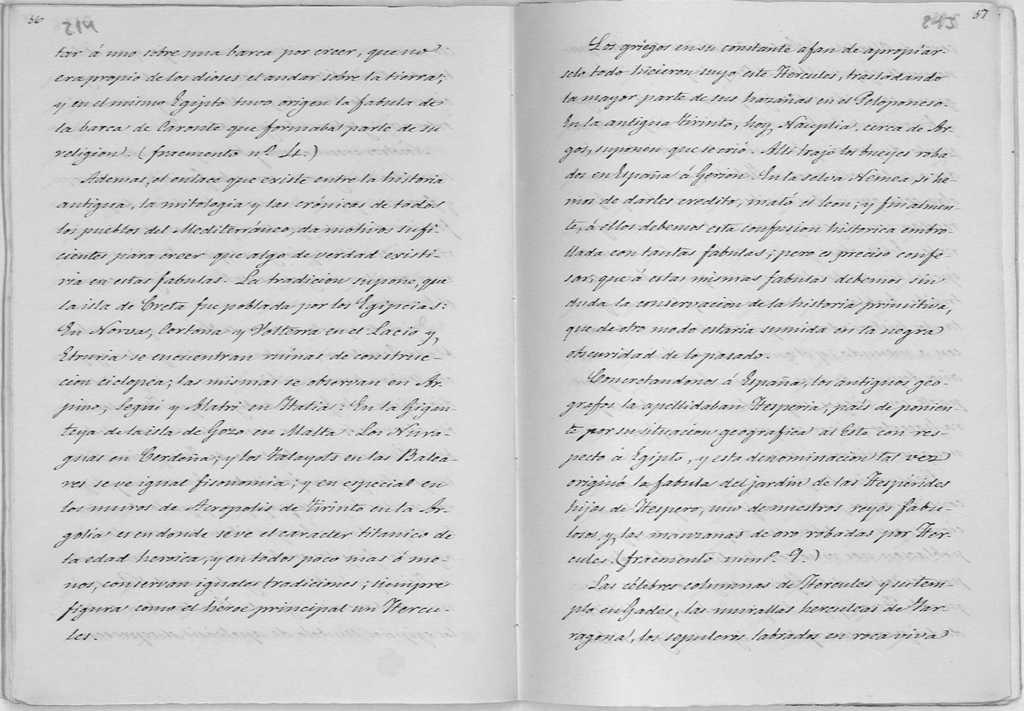What is the main object in the image? There is an open book in the image. What else can be seen in the image besides the open book? There are papers with writing on them in the image. What type of song is being sung by the eyes in the image? There are no eyes or singing in the image; it only features an open book and papers with writing on them. 